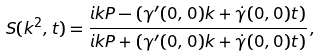<formula> <loc_0><loc_0><loc_500><loc_500>S ( k ^ { 2 } , t ) = \frac { i k P - ( \gamma ^ { \prime } ( 0 , 0 ) k + \dot { \gamma } ( 0 , 0 ) t ) } { i k P + ( \gamma ^ { \prime } ( 0 , 0 ) k + \dot { \gamma } ( 0 , 0 ) t ) } \, ,</formula> 